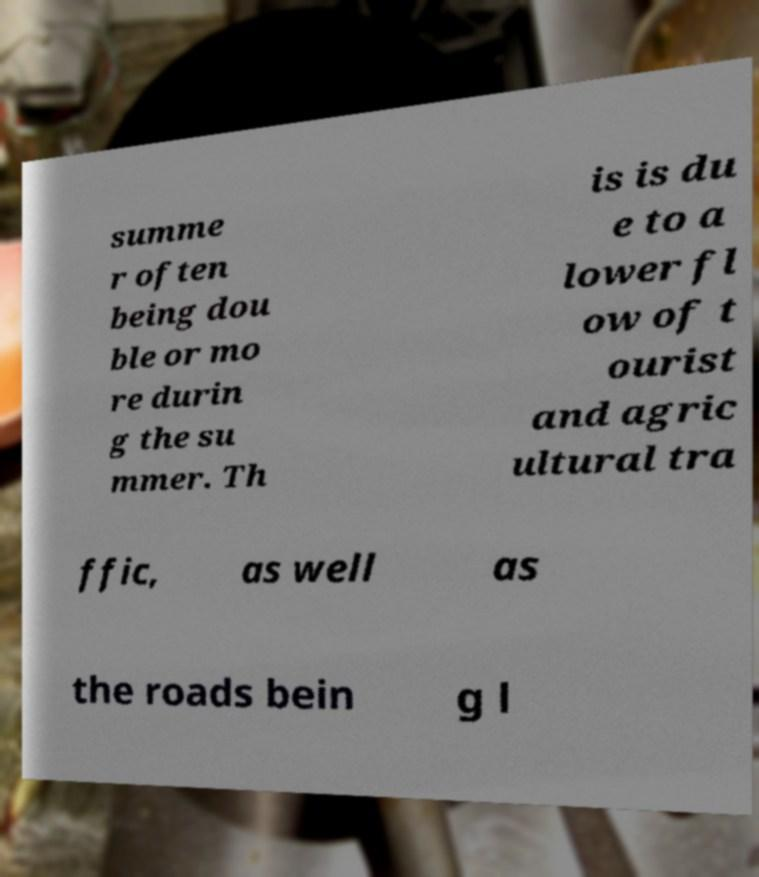Can you accurately transcribe the text from the provided image for me? summe r often being dou ble or mo re durin g the su mmer. Th is is du e to a lower fl ow of t ourist and agric ultural tra ffic, as well as the roads bein g l 